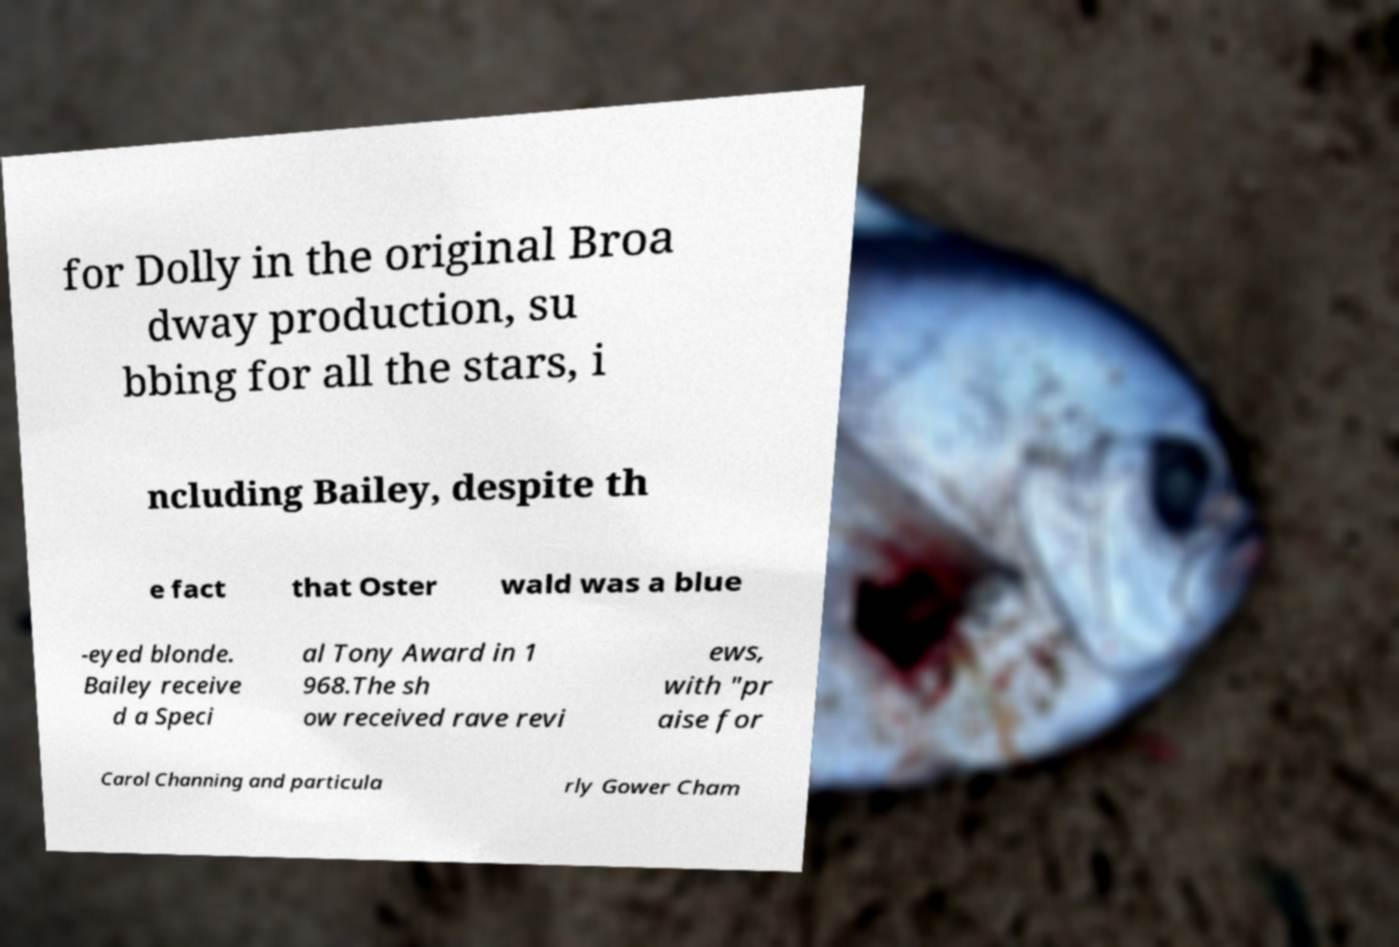Please read and relay the text visible in this image. What does it say? for Dolly in the original Broa dway production, su bbing for all the stars, i ncluding Bailey, despite th e fact that Oster wald was a blue -eyed blonde. Bailey receive d a Speci al Tony Award in 1 968.The sh ow received rave revi ews, with "pr aise for Carol Channing and particula rly Gower Cham 